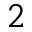<formula> <loc_0><loc_0><loc_500><loc_500>^ { 2 }</formula> 